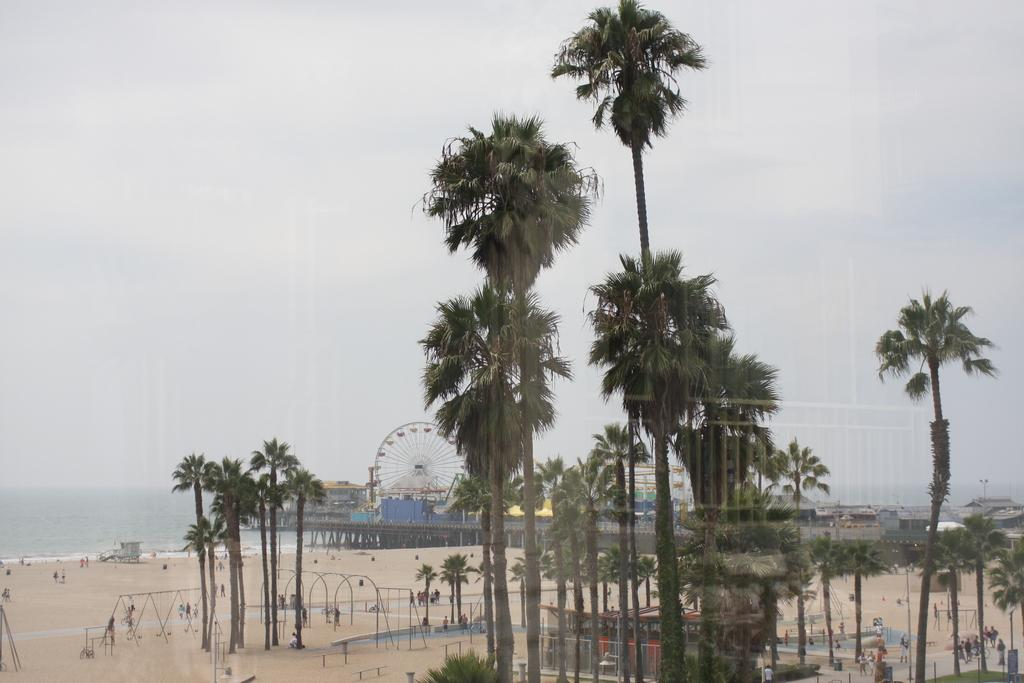What type of structure can be seen in the image? There is a building in the image. What other structures are present in the image? There is a shed in the image. Can you describe any objects in the image? There is a wheel in the image. What type of natural environment is visible in the image? The ocean is visible in the background of the image, and there are trees in the image. Where is the beach located in the image? The beach is on the left side of the image. What is visible at the top of the image? The sky is visible at the top of the image, and clouds are present in the sky. What type of spark can be seen coming from the door in the image? There is no door present in the image, so there cannot be any sparks coming from it. How does the beggar interact with the wheel in the image? There is no beggar present in the image, so there is no interaction with the wheel. 